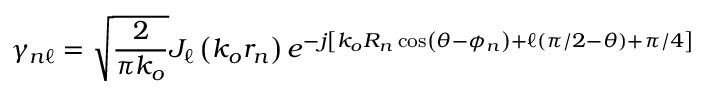Convert formula to latex. <formula><loc_0><loc_0><loc_500><loc_500>\gamma _ { n \ell } = \sqrt { \frac { 2 } { \pi k _ { o } } } J _ { \ell } \left ( k _ { o } r _ { n } \right ) e ^ { - j \left [ k _ { o } R _ { n } \cos \left ( \theta - \phi _ { n } \right ) + \ell ( \pi / 2 - \theta ) + \pi / 4 \right ] }</formula> 